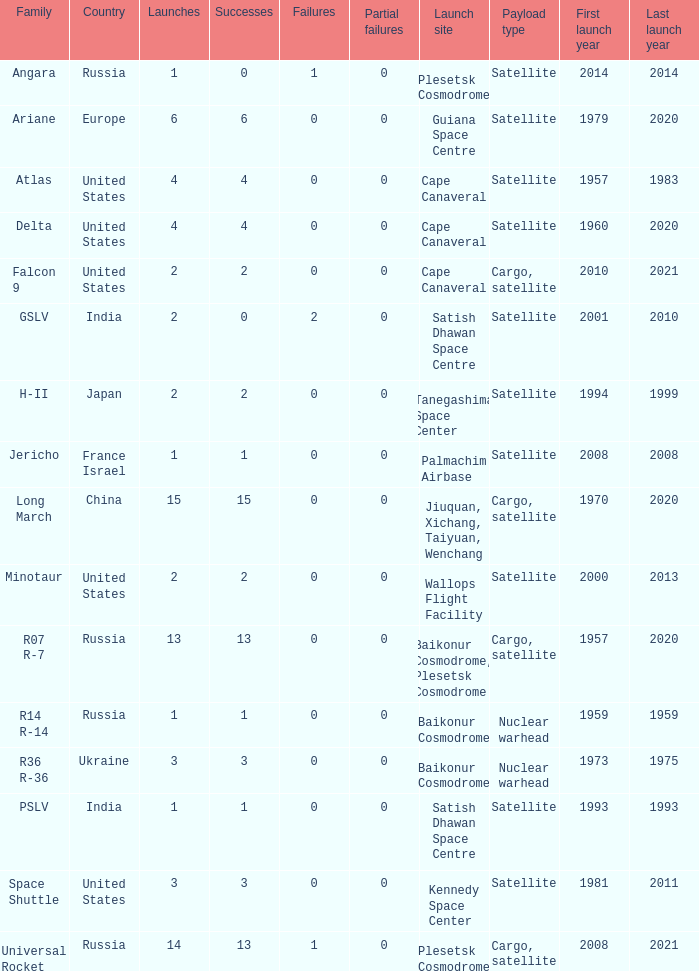What is the partial failure for the Country of russia, and a Failure larger than 0, and a Family of angara, and a Launch larger than 1? None. 